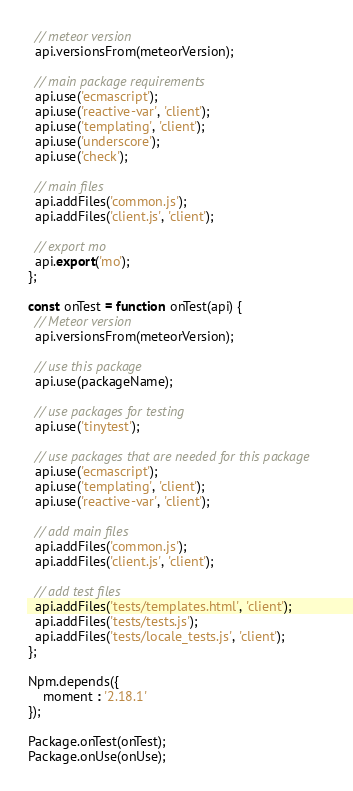Convert code to text. <code><loc_0><loc_0><loc_500><loc_500><_JavaScript_>  // meteor version
  api.versionsFrom(meteorVersion);

  // main package requirements
  api.use('ecmascript');
  api.use('reactive-var', 'client');
  api.use('templating', 'client');
  api.use('underscore');
  api.use('check');

  // main files
  api.addFiles('common.js');
  api.addFiles('client.js', 'client');

  // export mo
  api.export('mo');
};

const onTest = function onTest(api) {
  // Meteor version
  api.versionsFrom(meteorVersion);

  // use this package
  api.use(packageName);

  // use packages for testing
  api.use('tinytest');

  // use packages that are needed for this package
  api.use('ecmascript');
  api.use('templating', 'client');
  api.use('reactive-var', 'client');

  // add main files
  api.addFiles('common.js');
  api.addFiles('client.js', 'client');

  // add test files
  api.addFiles('tests/templates.html', 'client');
  api.addFiles('tests/tests.js');
  api.addFiles('tests/locale_tests.js', 'client');
};

Npm.depends({
    moment : '2.18.1'
});

Package.onTest(onTest);
Package.onUse(onUse);
</code> 